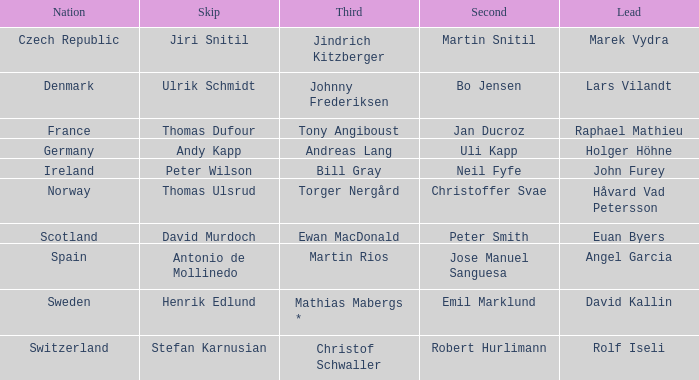In which third did angel garcia lead? Martin Rios. I'm looking to parse the entire table for insights. Could you assist me with that? {'header': ['Nation', 'Skip', 'Third', 'Second', 'Lead'], 'rows': [['Czech Republic', 'Jiri Snitil', 'Jindrich Kitzberger', 'Martin Snitil', 'Marek Vydra'], ['Denmark', 'Ulrik Schmidt', 'Johnny Frederiksen', 'Bo Jensen', 'Lars Vilandt'], ['France', 'Thomas Dufour', 'Tony Angiboust', 'Jan Ducroz', 'Raphael Mathieu'], ['Germany', 'Andy Kapp', 'Andreas Lang', 'Uli Kapp', 'Holger Höhne'], ['Ireland', 'Peter Wilson', 'Bill Gray', 'Neil Fyfe', 'John Furey'], ['Norway', 'Thomas Ulsrud', 'Torger Nergård', 'Christoffer Svae', 'Håvard Vad Petersson'], ['Scotland', 'David Murdoch', 'Ewan MacDonald', 'Peter Smith', 'Euan Byers'], ['Spain', 'Antonio de Mollinedo', 'Martin Rios', 'Jose Manuel Sanguesa', 'Angel Garcia'], ['Sweden', 'Henrik Edlund', 'Mathias Mabergs *', 'Emil Marklund', 'David Kallin'], ['Switzerland', 'Stefan Karnusian', 'Christof Schwaller', 'Robert Hurlimann', 'Rolf Iseli']]} 